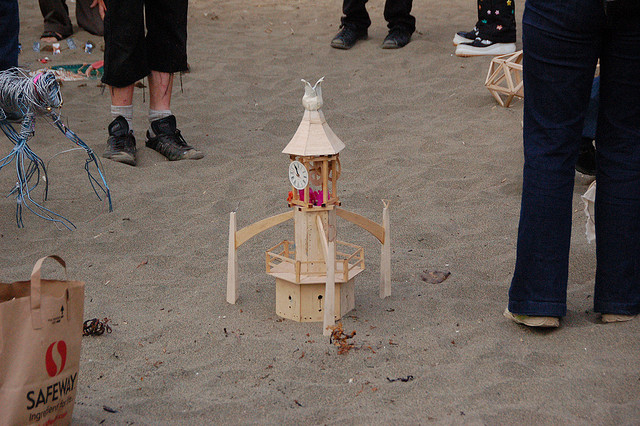Please identify all text content in this image. SAFEWAY 